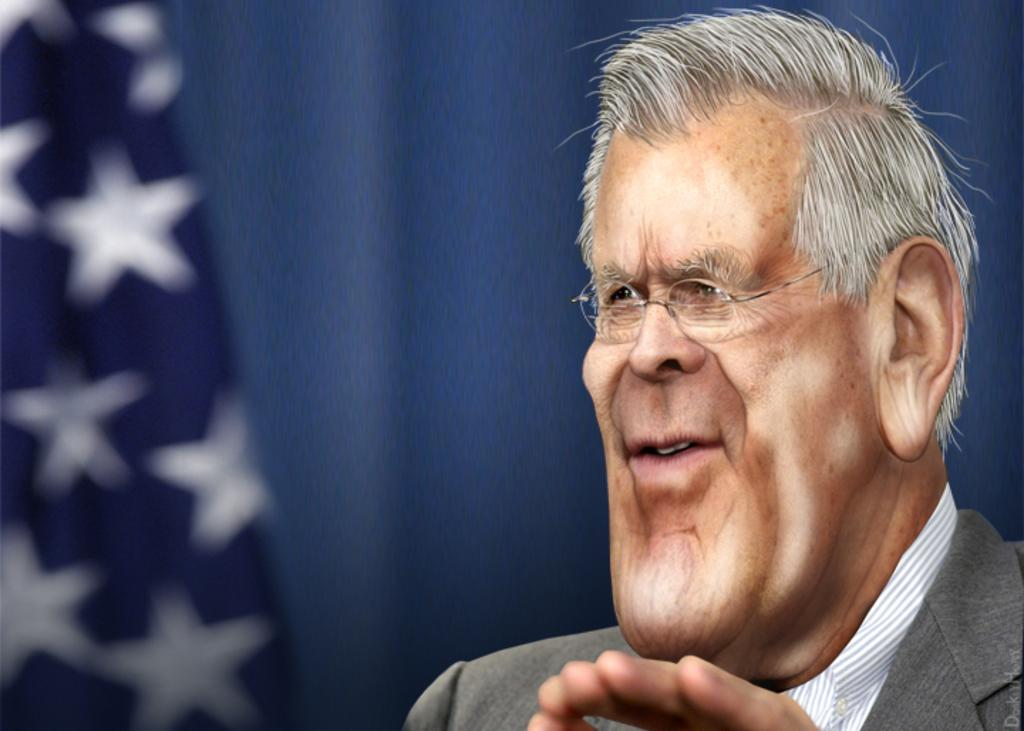What type of image is depicted in the picture? There is an animation image of a man in the image. What theory does the man in the image propose about the point of the universe? There is no mention of a theory or a point in the image, as it only depicts an animation of a man. 